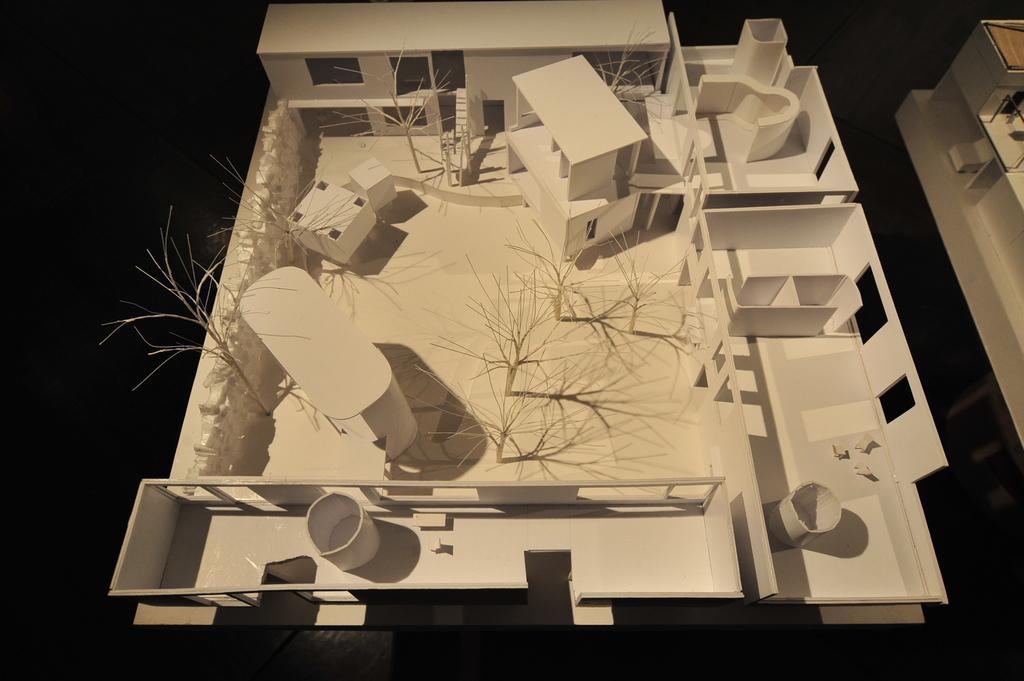Could you give a brief overview of what you see in this image? In this picture we can see miniature of house. In the background of the image it is dark. On the left side of the image we can see white object. 